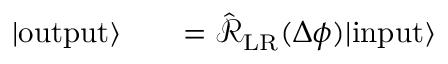Convert formula to latex. <formula><loc_0><loc_0><loc_500><loc_500>\begin{array} { r l r } { | o u t p u t \rangle } & { = \hat { \mathcal { R } } _ { L R } ( \Delta \phi ) | i n p u t \rangle } \end{array}</formula> 